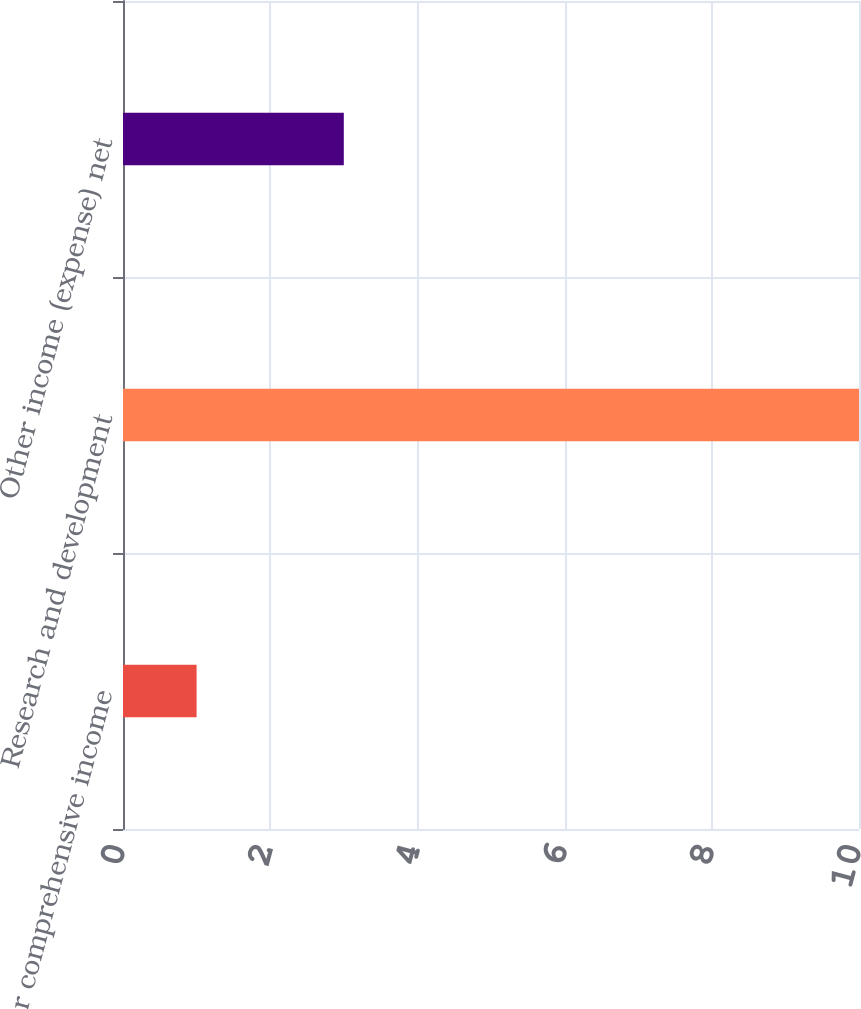Convert chart. <chart><loc_0><loc_0><loc_500><loc_500><bar_chart><fcel>Other comprehensive income<fcel>Research and development<fcel>Other income (expense) net<nl><fcel>1<fcel>10<fcel>3<nl></chart> 